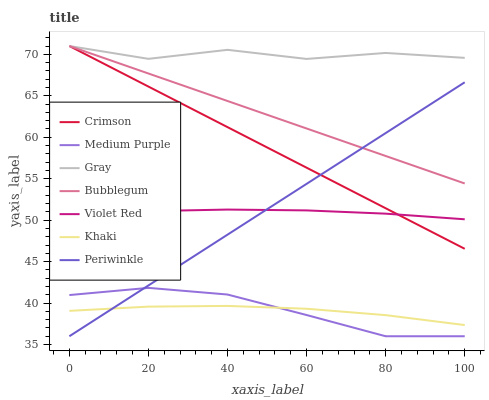Does Khaki have the minimum area under the curve?
Answer yes or no. Yes. Does Gray have the maximum area under the curve?
Answer yes or no. Yes. Does Violet Red have the minimum area under the curve?
Answer yes or no. No. Does Violet Red have the maximum area under the curve?
Answer yes or no. No. Is Crimson the smoothest?
Answer yes or no. Yes. Is Gray the roughest?
Answer yes or no. Yes. Is Violet Red the smoothest?
Answer yes or no. No. Is Violet Red the roughest?
Answer yes or no. No. Does Medium Purple have the lowest value?
Answer yes or no. Yes. Does Violet Red have the lowest value?
Answer yes or no. No. Does Crimson have the highest value?
Answer yes or no. Yes. Does Violet Red have the highest value?
Answer yes or no. No. Is Khaki less than Crimson?
Answer yes or no. Yes. Is Bubblegum greater than Violet Red?
Answer yes or no. Yes. Does Bubblegum intersect Periwinkle?
Answer yes or no. Yes. Is Bubblegum less than Periwinkle?
Answer yes or no. No. Is Bubblegum greater than Periwinkle?
Answer yes or no. No. Does Khaki intersect Crimson?
Answer yes or no. No. 